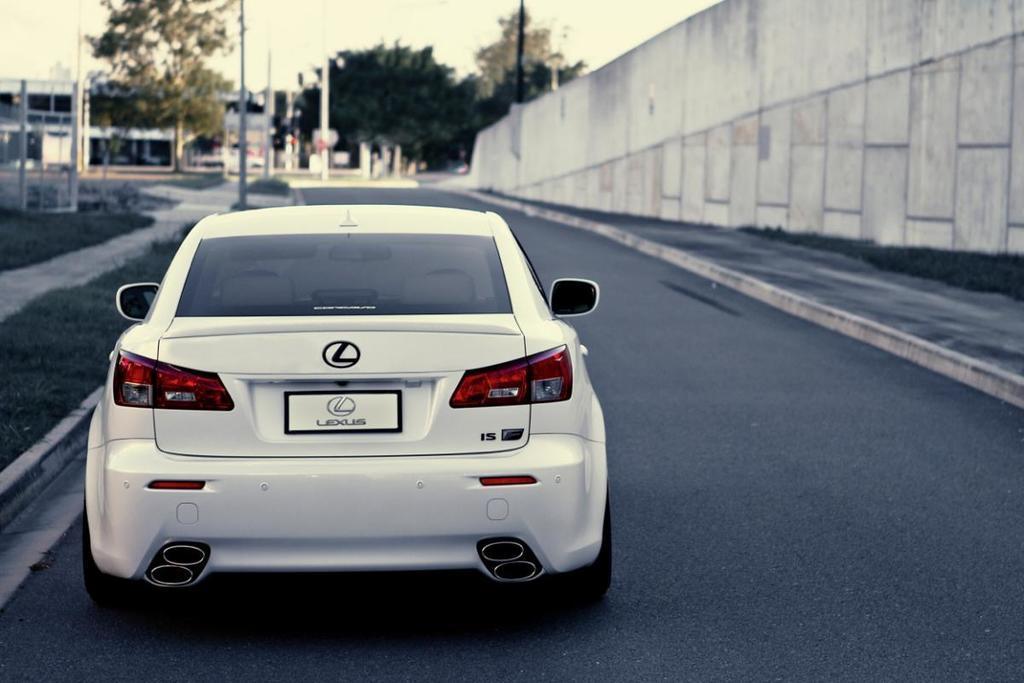Could you give a brief overview of what you see in this image? This picture is clicked outside the city. At the bottom, we see the road. In front of the picture, we see a white car. On the right side, we see a footpath and a wall in white color. On the left side, we see the grass and the poles. There are trees, buildings and poles in the background. At the top, we see the sky. This picture is blurred in the background. 